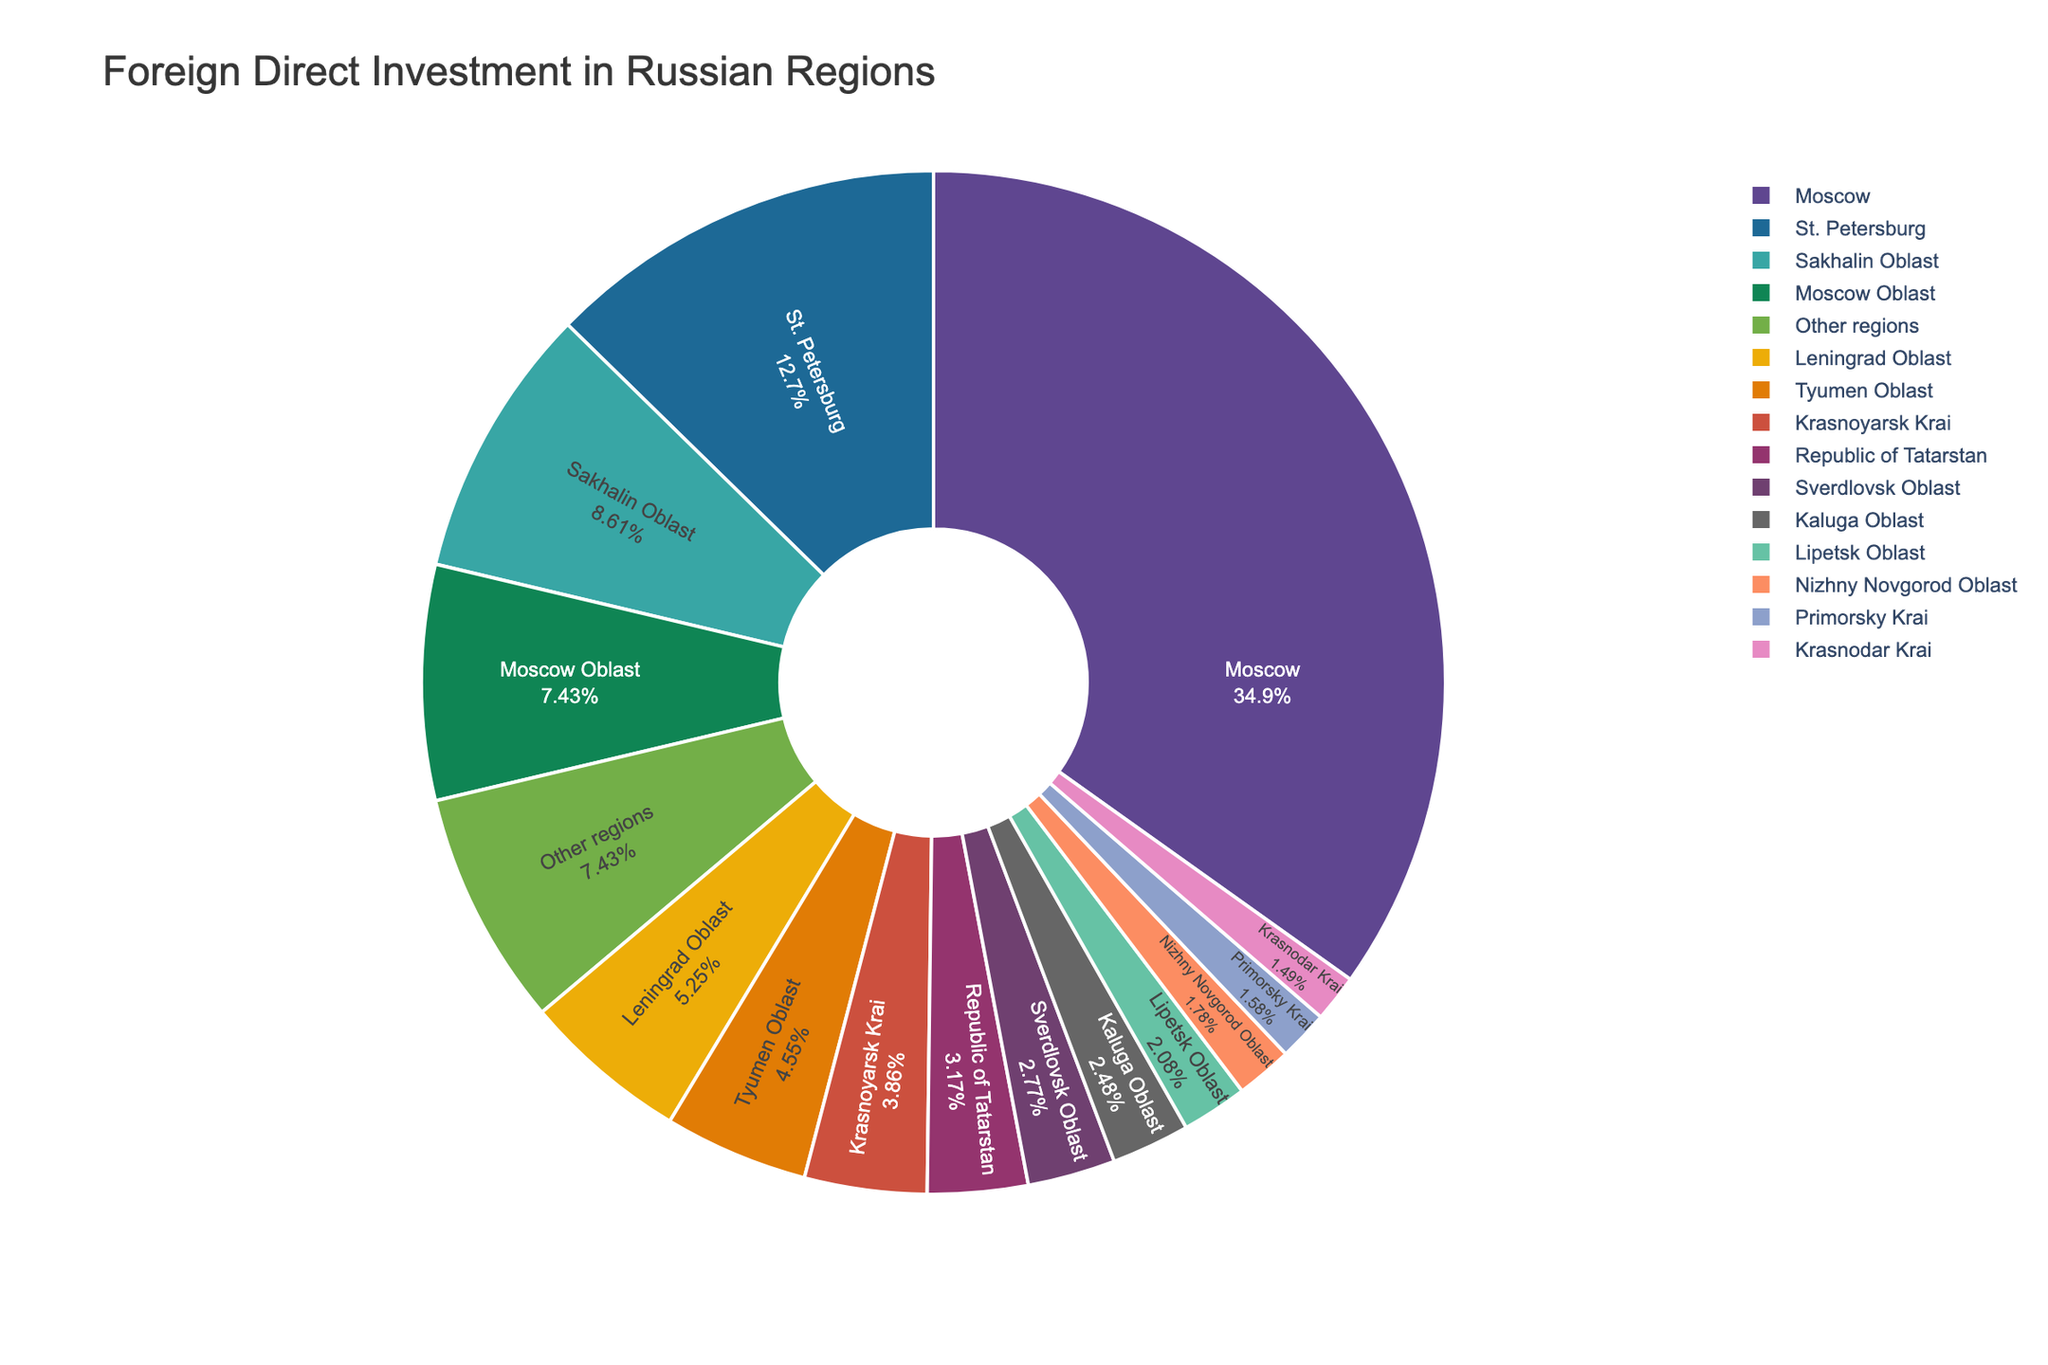Which region receives the highest percentage of FDI? The pie chart shows the breakdown of FDI percentages for various Russian regions. The largest segment represents the region with the highest percentage of FDI, which is labeled as Moscow with 35.2%.
Answer: Moscow What is the sum of the FDI percentages for Moscow and St. Petersburg? To find the sum of the FDI percentages for Moscow and St. Petersburg, add the FDI percentage of Moscow (35.2%) to the FDI percentage of St. Petersburg (12.8%). This yields 35.2% + 12.8% = 48.0%.
Answer: 48.0% Which region has a higher FDI percentage: Sakhalin Oblast or Tyumen Oblast? By comparing the FDI percentages, Sakhalin Oblast has 8.7% and Tyumen Oblast has 4.6%. Since 8.7% is greater than 4.6%, Sakhalin Oblast has a higher FDI percentage.
Answer: Sakhalin Oblast What is the combined FDI percentage for the regions categorized as "Other regions"? The pie chart labels a segment as "Other regions" with an FDI percentage of 7.5%. Therefore, the combined FDI percentage for these regions is 7.5%.
Answer: 7.5% Are there any regions with an FDI percentage less than 2%? Checking the pie chart, Nizhny Novgorod Oblast has 1.8%, and Primorsky Krai has 1.6%, both of which are less than 2%.
Answer: Yes Which region has a greater FDI percentage: Leningrad Oblast or Krasnoyarsk Krai? Comparing the FDI percentages, Leningrad Oblast has 5.3% and Krasnoyarsk Krai has 3.9%. Since 5.3% is greater than 3.9%, Leningrad Oblast has a greater FDI percentage.
Answer: Leningrad Oblast How much higher is the FDI percentage in Moscow than in the Republic of Tatarstan? Moscow has an FDI percentage of 35.2%, and the Republic of Tatarstan has 3.2%. The difference is 35.2% - 3.2% = 32.0%. So, FDI in Moscow is 32.0% higher.
Answer: 32.0% What is the average FDI percentage of the top three regions? The top three regions are Moscow (35.2%), St. Petersburg (12.8%), and Sakhalin Oblast (8.7%). The average FDI percentage is (35.2% + 12.8% + 8.7%) / 3 = 56.7% / 3 = 18.9%.
Answer: 18.9% Does Moscow contribute more than one-third of the total FDI? One-third of 100% is approximately 33.33%. Moscow contributes 35.2%, which is greater than 33.33%, so yes, Moscow contributes more than one-third of the total FDI.
Answer: Yes 